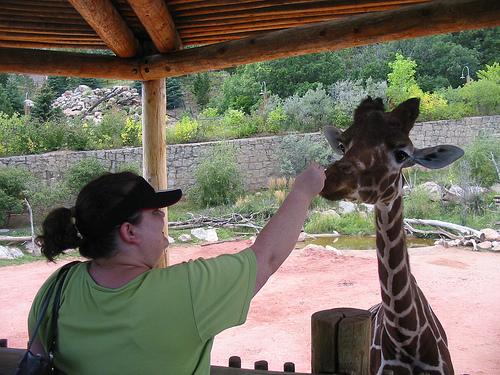What material is the roof comprised of?
Keep it brief. Wood. What animal is the woman feeding?
Write a very short answer. Giraffe. Is the giraffe hungry?
Quick response, please. Yes. What part of the giraffe is nearest to the woman?
Keep it brief. Mouth. What color hair does the woman have?
Write a very short answer. Brown. What is the woman wearing on her head?
Keep it brief. Visor. 